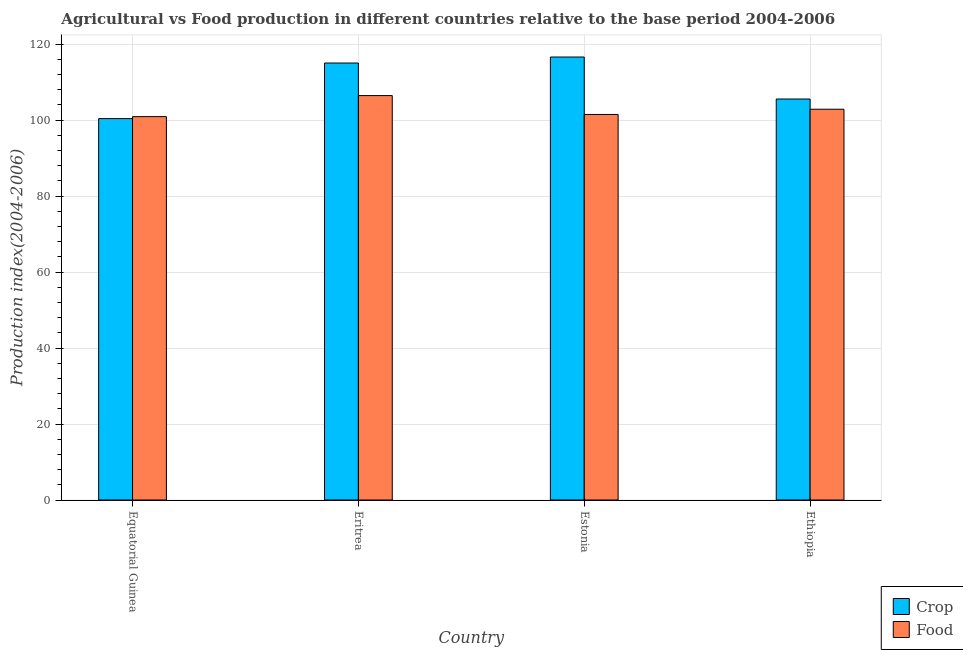How many different coloured bars are there?
Give a very brief answer. 2. Are the number of bars per tick equal to the number of legend labels?
Your response must be concise. Yes. How many bars are there on the 4th tick from the right?
Provide a short and direct response. 2. What is the label of the 4th group of bars from the left?
Your answer should be compact. Ethiopia. In how many cases, is the number of bars for a given country not equal to the number of legend labels?
Give a very brief answer. 0. What is the crop production index in Equatorial Guinea?
Offer a terse response. 100.4. Across all countries, what is the maximum crop production index?
Your answer should be compact. 116.61. Across all countries, what is the minimum crop production index?
Keep it short and to the point. 100.4. In which country was the food production index maximum?
Keep it short and to the point. Eritrea. In which country was the food production index minimum?
Your answer should be compact. Equatorial Guinea. What is the total food production index in the graph?
Keep it short and to the point. 411.74. What is the difference between the food production index in Estonia and that in Ethiopia?
Provide a short and direct response. -1.38. What is the difference between the food production index in Equatorial Guinea and the crop production index in Eritrea?
Provide a short and direct response. -14.11. What is the average crop production index per country?
Keep it short and to the point. 109.4. What is the difference between the food production index and crop production index in Ethiopia?
Provide a short and direct response. -2.69. What is the ratio of the crop production index in Equatorial Guinea to that in Eritrea?
Keep it short and to the point. 0.87. Is the difference between the food production index in Equatorial Guinea and Estonia greater than the difference between the crop production index in Equatorial Guinea and Estonia?
Offer a terse response. Yes. What is the difference between the highest and the second highest crop production index?
Offer a terse response. 1.58. What is the difference between the highest and the lowest crop production index?
Your answer should be compact. 16.21. What does the 1st bar from the left in Ethiopia represents?
Provide a short and direct response. Crop. What does the 1st bar from the right in Eritrea represents?
Keep it short and to the point. Food. How many bars are there?
Give a very brief answer. 8. Are all the bars in the graph horizontal?
Offer a very short reply. No. How many countries are there in the graph?
Provide a short and direct response. 4. Does the graph contain any zero values?
Make the answer very short. No. Where does the legend appear in the graph?
Your answer should be compact. Bottom right. How many legend labels are there?
Provide a succinct answer. 2. What is the title of the graph?
Keep it short and to the point. Agricultural vs Food production in different countries relative to the base period 2004-2006. What is the label or title of the Y-axis?
Your answer should be very brief. Production index(2004-2006). What is the Production index(2004-2006) of Crop in Equatorial Guinea?
Offer a very short reply. 100.4. What is the Production index(2004-2006) of Food in Equatorial Guinea?
Your answer should be compact. 100.92. What is the Production index(2004-2006) of Crop in Eritrea?
Your answer should be compact. 115.03. What is the Production index(2004-2006) in Food in Eritrea?
Give a very brief answer. 106.46. What is the Production index(2004-2006) in Crop in Estonia?
Offer a very short reply. 116.61. What is the Production index(2004-2006) in Food in Estonia?
Provide a short and direct response. 101.49. What is the Production index(2004-2006) of Crop in Ethiopia?
Keep it short and to the point. 105.56. What is the Production index(2004-2006) in Food in Ethiopia?
Provide a succinct answer. 102.87. Across all countries, what is the maximum Production index(2004-2006) in Crop?
Your answer should be compact. 116.61. Across all countries, what is the maximum Production index(2004-2006) of Food?
Your answer should be compact. 106.46. Across all countries, what is the minimum Production index(2004-2006) in Crop?
Give a very brief answer. 100.4. Across all countries, what is the minimum Production index(2004-2006) of Food?
Make the answer very short. 100.92. What is the total Production index(2004-2006) in Crop in the graph?
Ensure brevity in your answer.  437.6. What is the total Production index(2004-2006) in Food in the graph?
Give a very brief answer. 411.74. What is the difference between the Production index(2004-2006) in Crop in Equatorial Guinea and that in Eritrea?
Your answer should be compact. -14.63. What is the difference between the Production index(2004-2006) of Food in Equatorial Guinea and that in Eritrea?
Offer a very short reply. -5.54. What is the difference between the Production index(2004-2006) of Crop in Equatorial Guinea and that in Estonia?
Provide a short and direct response. -16.21. What is the difference between the Production index(2004-2006) in Food in Equatorial Guinea and that in Estonia?
Give a very brief answer. -0.57. What is the difference between the Production index(2004-2006) in Crop in Equatorial Guinea and that in Ethiopia?
Provide a succinct answer. -5.16. What is the difference between the Production index(2004-2006) in Food in Equatorial Guinea and that in Ethiopia?
Make the answer very short. -1.95. What is the difference between the Production index(2004-2006) of Crop in Eritrea and that in Estonia?
Your answer should be compact. -1.58. What is the difference between the Production index(2004-2006) in Food in Eritrea and that in Estonia?
Your response must be concise. 4.97. What is the difference between the Production index(2004-2006) of Crop in Eritrea and that in Ethiopia?
Give a very brief answer. 9.47. What is the difference between the Production index(2004-2006) in Food in Eritrea and that in Ethiopia?
Offer a terse response. 3.59. What is the difference between the Production index(2004-2006) of Crop in Estonia and that in Ethiopia?
Your answer should be very brief. 11.05. What is the difference between the Production index(2004-2006) of Food in Estonia and that in Ethiopia?
Your answer should be compact. -1.38. What is the difference between the Production index(2004-2006) of Crop in Equatorial Guinea and the Production index(2004-2006) of Food in Eritrea?
Make the answer very short. -6.06. What is the difference between the Production index(2004-2006) in Crop in Equatorial Guinea and the Production index(2004-2006) in Food in Estonia?
Your answer should be very brief. -1.09. What is the difference between the Production index(2004-2006) in Crop in Equatorial Guinea and the Production index(2004-2006) in Food in Ethiopia?
Your answer should be very brief. -2.47. What is the difference between the Production index(2004-2006) in Crop in Eritrea and the Production index(2004-2006) in Food in Estonia?
Give a very brief answer. 13.54. What is the difference between the Production index(2004-2006) of Crop in Eritrea and the Production index(2004-2006) of Food in Ethiopia?
Offer a terse response. 12.16. What is the difference between the Production index(2004-2006) in Crop in Estonia and the Production index(2004-2006) in Food in Ethiopia?
Give a very brief answer. 13.74. What is the average Production index(2004-2006) in Crop per country?
Your response must be concise. 109.4. What is the average Production index(2004-2006) of Food per country?
Offer a very short reply. 102.94. What is the difference between the Production index(2004-2006) of Crop and Production index(2004-2006) of Food in Equatorial Guinea?
Your response must be concise. -0.52. What is the difference between the Production index(2004-2006) in Crop and Production index(2004-2006) in Food in Eritrea?
Keep it short and to the point. 8.57. What is the difference between the Production index(2004-2006) in Crop and Production index(2004-2006) in Food in Estonia?
Offer a terse response. 15.12. What is the difference between the Production index(2004-2006) in Crop and Production index(2004-2006) in Food in Ethiopia?
Ensure brevity in your answer.  2.69. What is the ratio of the Production index(2004-2006) of Crop in Equatorial Guinea to that in Eritrea?
Provide a short and direct response. 0.87. What is the ratio of the Production index(2004-2006) in Food in Equatorial Guinea to that in Eritrea?
Provide a succinct answer. 0.95. What is the ratio of the Production index(2004-2006) in Crop in Equatorial Guinea to that in Estonia?
Provide a short and direct response. 0.86. What is the ratio of the Production index(2004-2006) in Crop in Equatorial Guinea to that in Ethiopia?
Provide a short and direct response. 0.95. What is the ratio of the Production index(2004-2006) in Food in Equatorial Guinea to that in Ethiopia?
Your response must be concise. 0.98. What is the ratio of the Production index(2004-2006) of Crop in Eritrea to that in Estonia?
Your response must be concise. 0.99. What is the ratio of the Production index(2004-2006) of Food in Eritrea to that in Estonia?
Keep it short and to the point. 1.05. What is the ratio of the Production index(2004-2006) in Crop in Eritrea to that in Ethiopia?
Your answer should be very brief. 1.09. What is the ratio of the Production index(2004-2006) in Food in Eritrea to that in Ethiopia?
Provide a short and direct response. 1.03. What is the ratio of the Production index(2004-2006) of Crop in Estonia to that in Ethiopia?
Give a very brief answer. 1.1. What is the ratio of the Production index(2004-2006) in Food in Estonia to that in Ethiopia?
Offer a terse response. 0.99. What is the difference between the highest and the second highest Production index(2004-2006) in Crop?
Give a very brief answer. 1.58. What is the difference between the highest and the second highest Production index(2004-2006) of Food?
Offer a terse response. 3.59. What is the difference between the highest and the lowest Production index(2004-2006) of Crop?
Keep it short and to the point. 16.21. What is the difference between the highest and the lowest Production index(2004-2006) in Food?
Ensure brevity in your answer.  5.54. 